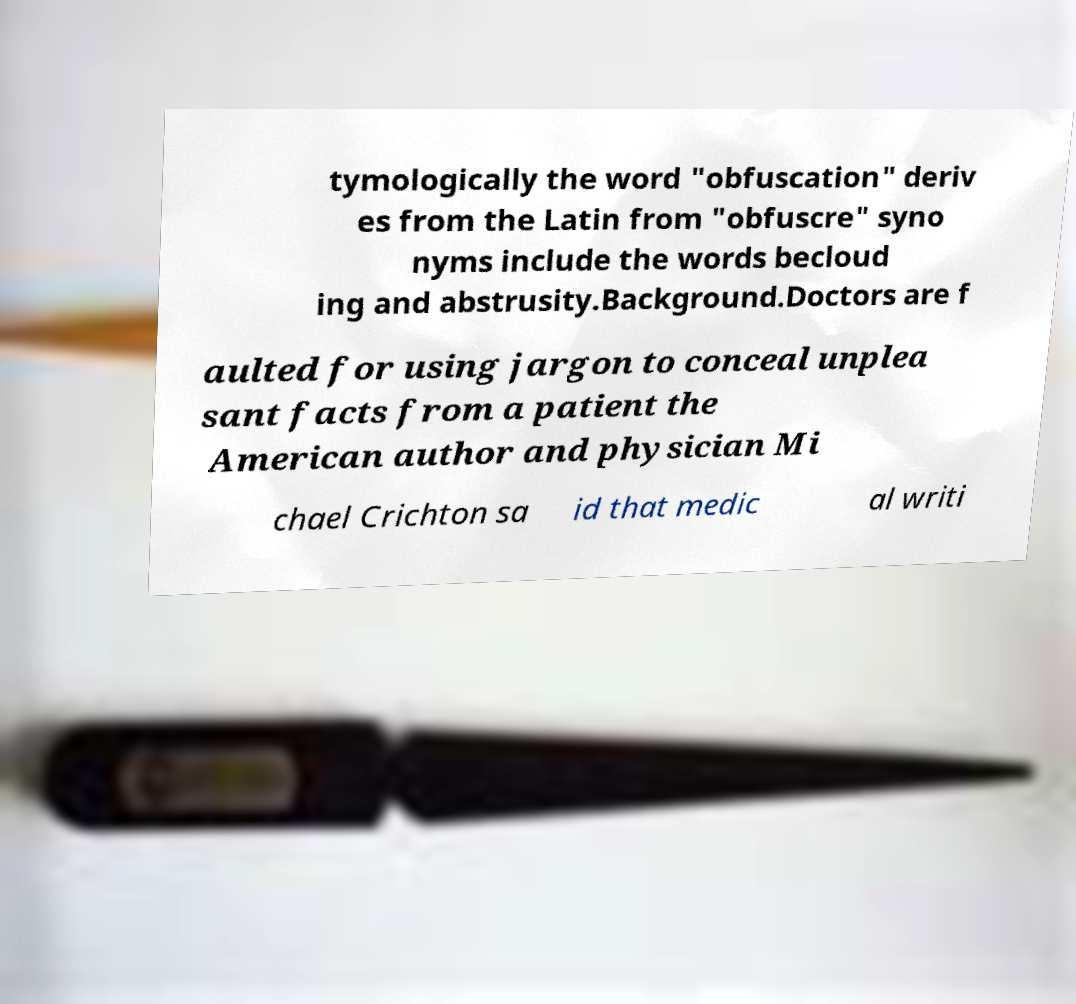Can you accurately transcribe the text from the provided image for me? tymologically the word "obfuscation" deriv es from the Latin from "obfuscre" syno nyms include the words becloud ing and abstrusity.Background.Doctors are f aulted for using jargon to conceal unplea sant facts from a patient the American author and physician Mi chael Crichton sa id that medic al writi 